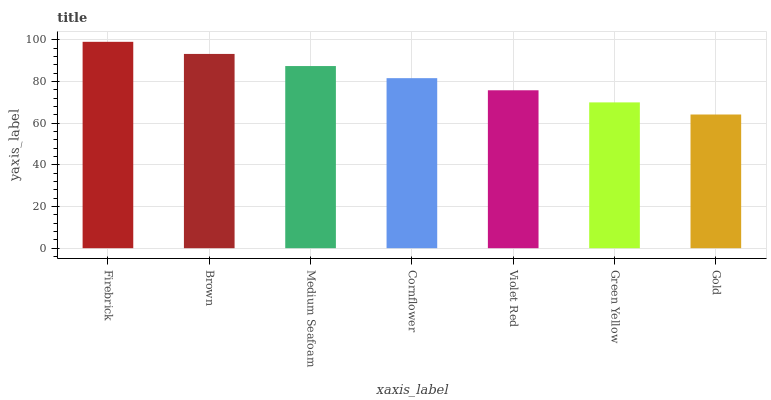Is Gold the minimum?
Answer yes or no. Yes. Is Firebrick the maximum?
Answer yes or no. Yes. Is Brown the minimum?
Answer yes or no. No. Is Brown the maximum?
Answer yes or no. No. Is Firebrick greater than Brown?
Answer yes or no. Yes. Is Brown less than Firebrick?
Answer yes or no. Yes. Is Brown greater than Firebrick?
Answer yes or no. No. Is Firebrick less than Brown?
Answer yes or no. No. Is Cornflower the high median?
Answer yes or no. Yes. Is Cornflower the low median?
Answer yes or no. Yes. Is Gold the high median?
Answer yes or no. No. Is Firebrick the low median?
Answer yes or no. No. 